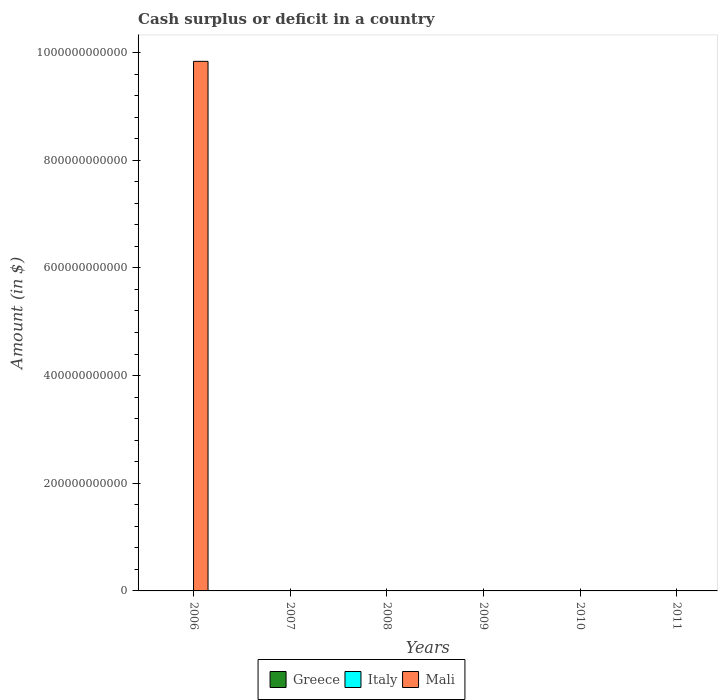Are the number of bars on each tick of the X-axis equal?
Ensure brevity in your answer.  No. How many bars are there on the 4th tick from the right?
Ensure brevity in your answer.  0. Across all years, what is the maximum amount of cash surplus or deficit in Mali?
Provide a succinct answer. 9.83e+11. Across all years, what is the minimum amount of cash surplus or deficit in Greece?
Your response must be concise. 0. What is the difference between the amount of cash surplus or deficit in Mali in 2008 and the amount of cash surplus or deficit in Italy in 2010?
Offer a very short reply. 0. What is the average amount of cash surplus or deficit in Mali per year?
Ensure brevity in your answer.  1.64e+11. In how many years, is the amount of cash surplus or deficit in Mali greater than 400000000000 $?
Offer a terse response. 1. What is the difference between the highest and the lowest amount of cash surplus or deficit in Mali?
Provide a short and direct response. 9.83e+11. How many bars are there?
Make the answer very short. 1. Are all the bars in the graph horizontal?
Offer a very short reply. No. How many years are there in the graph?
Offer a very short reply. 6. What is the difference between two consecutive major ticks on the Y-axis?
Provide a succinct answer. 2.00e+11. Are the values on the major ticks of Y-axis written in scientific E-notation?
Offer a terse response. No. Does the graph contain grids?
Your answer should be very brief. No. How many legend labels are there?
Provide a succinct answer. 3. What is the title of the graph?
Keep it short and to the point. Cash surplus or deficit in a country. What is the label or title of the X-axis?
Provide a short and direct response. Years. What is the label or title of the Y-axis?
Give a very brief answer. Amount (in $). What is the Amount (in $) of Greece in 2006?
Provide a succinct answer. 0. What is the Amount (in $) in Mali in 2006?
Provide a succinct answer. 9.83e+11. What is the Amount (in $) in Italy in 2008?
Make the answer very short. 0. What is the Amount (in $) in Mali in 2008?
Offer a terse response. 0. What is the Amount (in $) of Greece in 2010?
Your response must be concise. 0. What is the Amount (in $) of Greece in 2011?
Ensure brevity in your answer.  0. What is the Amount (in $) of Mali in 2011?
Provide a short and direct response. 0. Across all years, what is the maximum Amount (in $) in Mali?
Make the answer very short. 9.83e+11. What is the total Amount (in $) in Greece in the graph?
Offer a terse response. 0. What is the total Amount (in $) in Mali in the graph?
Provide a succinct answer. 9.83e+11. What is the average Amount (in $) in Greece per year?
Provide a succinct answer. 0. What is the average Amount (in $) in Mali per year?
Your answer should be very brief. 1.64e+11. What is the difference between the highest and the lowest Amount (in $) in Mali?
Your response must be concise. 9.83e+11. 